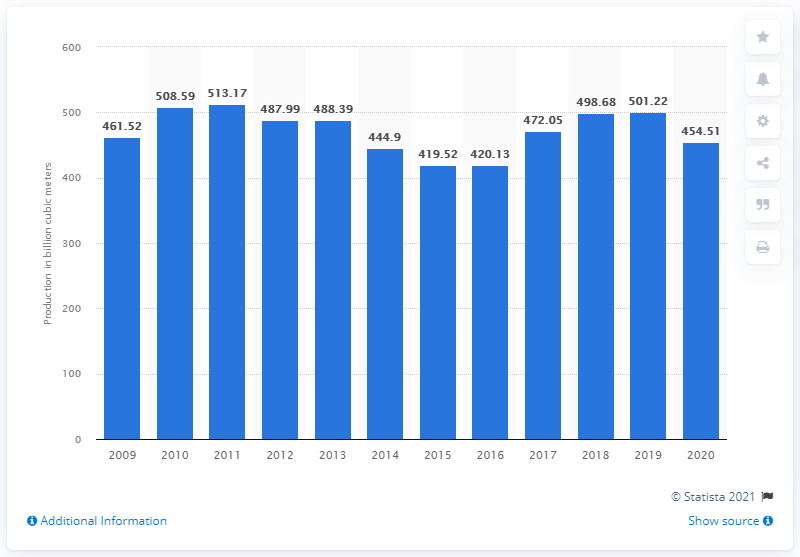Draw attention to some important aspects in this diagram. In 2020, Gazprom produced 454.51 cubic meters of natural gas in Russia. 